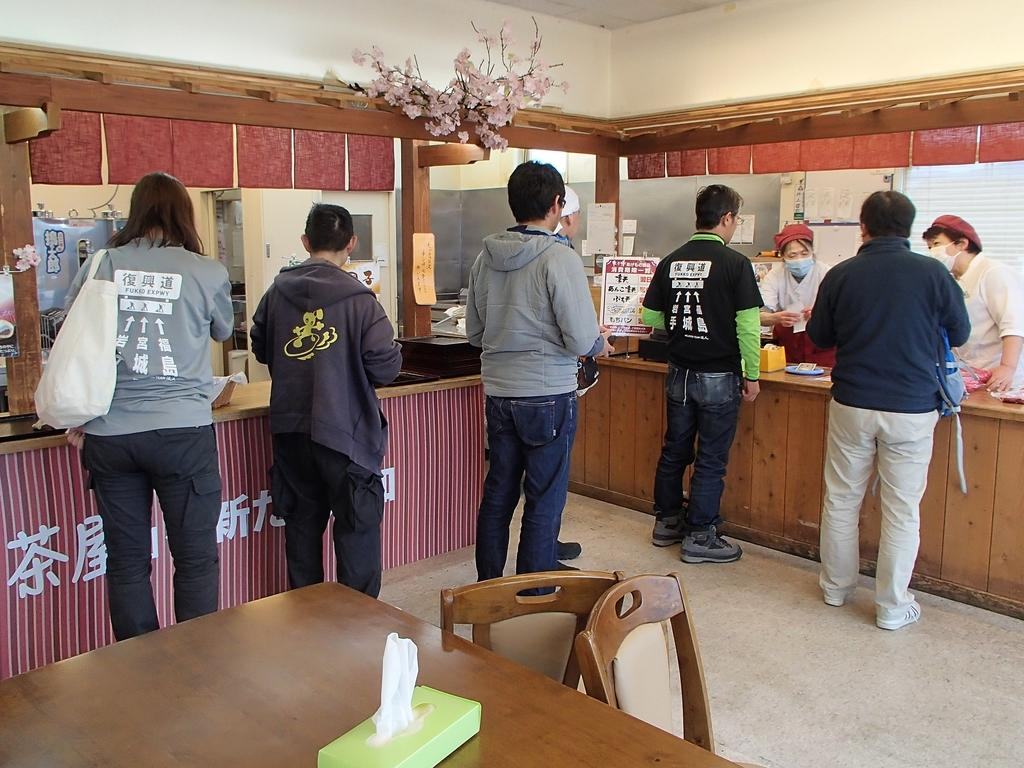What are the people in the image doing? The people in the image are standing in a line. What can be seen on the left side of the image? There is a dining table on the left side of the image. Are there any chairs associated with the dining table? Yes, there are chairs associated with the dining table. What month is the rat celebrating its birthday in the image? There is no rat present in the image, so it is not possible to determine the month of its birthday. 